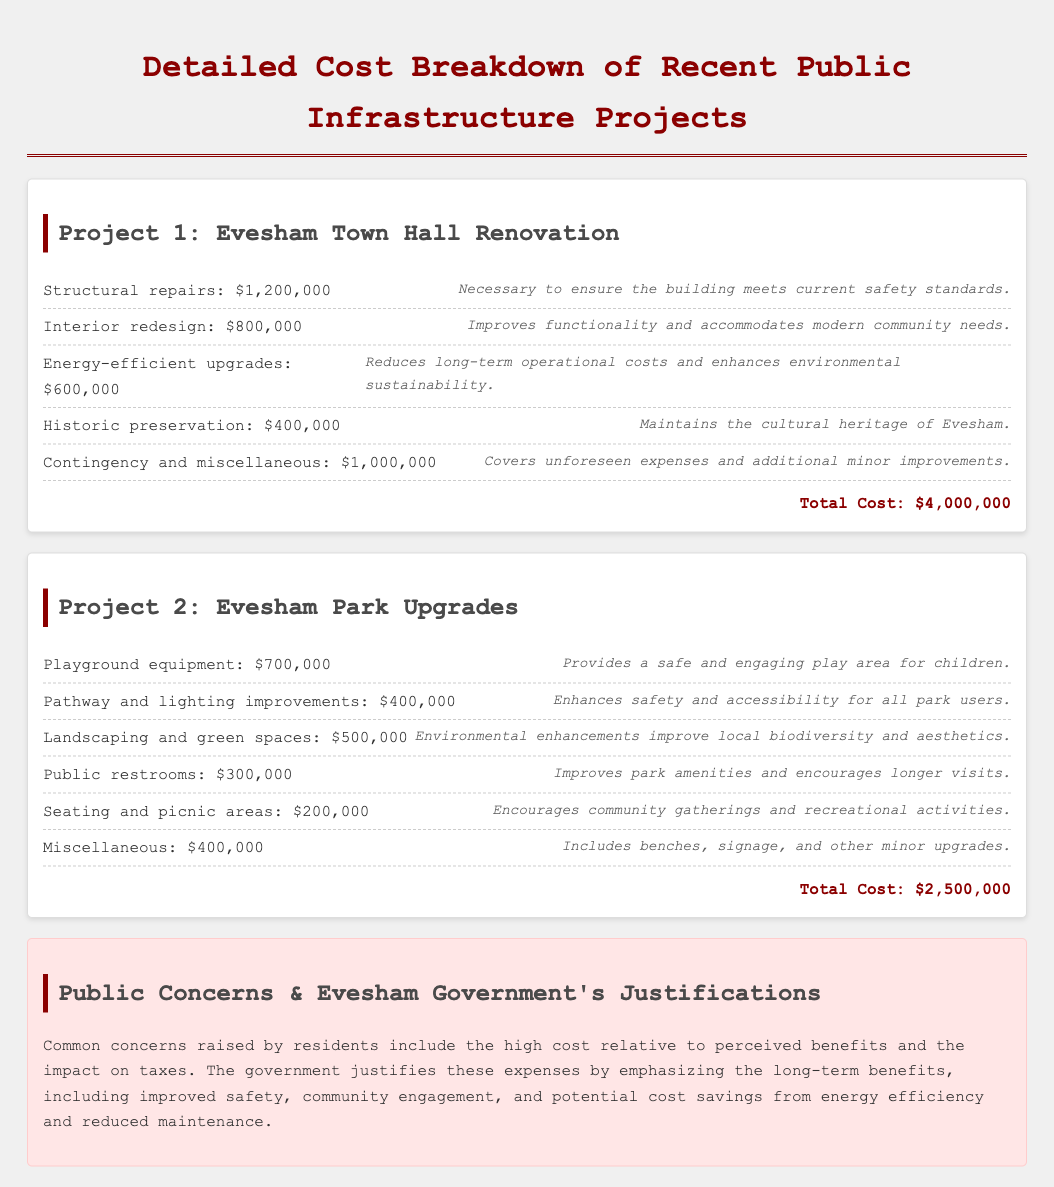What is the total cost of the Evesham Town Hall Renovation? The total cost can be found at the bottom of the project details, which is $4,000,000.
Answer: $4,000,000 What is the expense for playground equipment in Evesham Park Upgrades? The amount for playground equipment is specified in the document as $700,000.
Answer: $700,000 What is the justification for energy-efficient upgrades in the Town Hall project? The justification for energy-efficient upgrades is to reduce long-term operational costs and enhance environmental sustainability.
Answer: Reduces long-term operational costs and enhances environmental sustainability How much was allocated for landscaping and green spaces in Evesham Park Upgrades? The document states the cost for landscaping and green spaces is $500,000.
Answer: $500,000 What is the total cost of the Evesham Park Upgrades? The total cost provided at the end of the park upgrades project is $2,500,000.
Answer: $2,500,000 What common concern is raised by residents regarding the infrastructure projects? Residents commonly raise concerns about the high cost relative to perceived benefits.
Answer: High cost relative to perceived benefits What amount is designated for contingency and miscellaneous expenses in the Town Hall renovation? The document specifies a total of $1,000,000 for contingency and miscellaneous expenses.
Answer: $1,000,000 What are the justifications emphasized by the government for the expenses? The government justifies the expenses by highlighting long-term benefits such as improved safety, community engagement, and potential cost savings.
Answer: Improved safety, community engagement, and potential cost savings How much was spent on interior redesign for the Town Hall renovation? The specified cost for interior redesign in the document is $800,000.
Answer: $800,000 